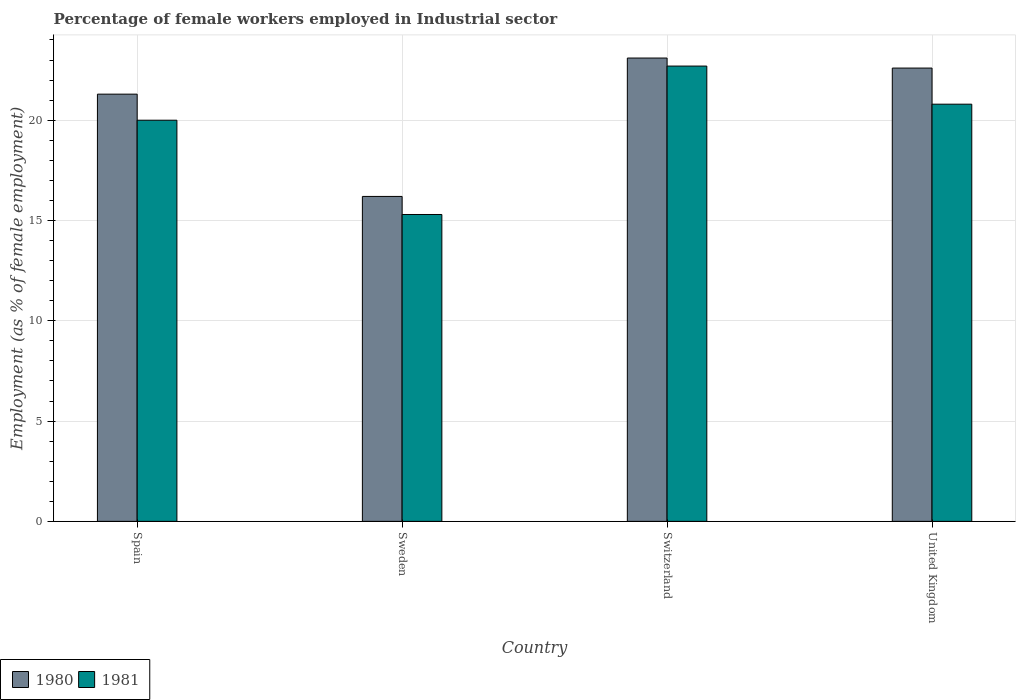How many different coloured bars are there?
Give a very brief answer. 2. How many groups of bars are there?
Provide a short and direct response. 4. Are the number of bars on each tick of the X-axis equal?
Your answer should be compact. Yes. In how many cases, is the number of bars for a given country not equal to the number of legend labels?
Offer a terse response. 0. What is the percentage of females employed in Industrial sector in 1980 in Switzerland?
Ensure brevity in your answer.  23.1. Across all countries, what is the maximum percentage of females employed in Industrial sector in 1980?
Provide a short and direct response. 23.1. Across all countries, what is the minimum percentage of females employed in Industrial sector in 1981?
Make the answer very short. 15.3. In which country was the percentage of females employed in Industrial sector in 1981 maximum?
Make the answer very short. Switzerland. In which country was the percentage of females employed in Industrial sector in 1980 minimum?
Make the answer very short. Sweden. What is the total percentage of females employed in Industrial sector in 1981 in the graph?
Ensure brevity in your answer.  78.8. What is the difference between the percentage of females employed in Industrial sector in 1981 in Sweden and that in Switzerland?
Keep it short and to the point. -7.4. What is the difference between the percentage of females employed in Industrial sector in 1980 in Sweden and the percentage of females employed in Industrial sector in 1981 in Spain?
Give a very brief answer. -3.8. What is the average percentage of females employed in Industrial sector in 1980 per country?
Ensure brevity in your answer.  20.8. What is the difference between the percentage of females employed in Industrial sector of/in 1980 and percentage of females employed in Industrial sector of/in 1981 in Switzerland?
Provide a short and direct response. 0.4. In how many countries, is the percentage of females employed in Industrial sector in 1981 greater than 4 %?
Give a very brief answer. 4. What is the ratio of the percentage of females employed in Industrial sector in 1980 in Sweden to that in Switzerland?
Your response must be concise. 0.7. Is the percentage of females employed in Industrial sector in 1981 in Spain less than that in United Kingdom?
Make the answer very short. Yes. What is the difference between the highest and the second highest percentage of females employed in Industrial sector in 1980?
Ensure brevity in your answer.  -1.3. What is the difference between the highest and the lowest percentage of females employed in Industrial sector in 1981?
Your answer should be very brief. 7.4. In how many countries, is the percentage of females employed in Industrial sector in 1980 greater than the average percentage of females employed in Industrial sector in 1980 taken over all countries?
Your answer should be very brief. 3. Is the sum of the percentage of females employed in Industrial sector in 1980 in Spain and Sweden greater than the maximum percentage of females employed in Industrial sector in 1981 across all countries?
Provide a short and direct response. Yes. What does the 1st bar from the right in United Kingdom represents?
Keep it short and to the point. 1981. Are all the bars in the graph horizontal?
Your answer should be compact. No. How many countries are there in the graph?
Offer a terse response. 4. Are the values on the major ticks of Y-axis written in scientific E-notation?
Keep it short and to the point. No. Does the graph contain any zero values?
Offer a terse response. No. Where does the legend appear in the graph?
Your answer should be compact. Bottom left. What is the title of the graph?
Offer a terse response. Percentage of female workers employed in Industrial sector. Does "1992" appear as one of the legend labels in the graph?
Keep it short and to the point. No. What is the label or title of the Y-axis?
Offer a very short reply. Employment (as % of female employment). What is the Employment (as % of female employment) in 1980 in Spain?
Offer a terse response. 21.3. What is the Employment (as % of female employment) of 1981 in Spain?
Your response must be concise. 20. What is the Employment (as % of female employment) in 1980 in Sweden?
Offer a terse response. 16.2. What is the Employment (as % of female employment) of 1981 in Sweden?
Your response must be concise. 15.3. What is the Employment (as % of female employment) of 1980 in Switzerland?
Give a very brief answer. 23.1. What is the Employment (as % of female employment) of 1981 in Switzerland?
Provide a short and direct response. 22.7. What is the Employment (as % of female employment) of 1980 in United Kingdom?
Provide a short and direct response. 22.6. What is the Employment (as % of female employment) in 1981 in United Kingdom?
Make the answer very short. 20.8. Across all countries, what is the maximum Employment (as % of female employment) of 1980?
Provide a short and direct response. 23.1. Across all countries, what is the maximum Employment (as % of female employment) in 1981?
Make the answer very short. 22.7. Across all countries, what is the minimum Employment (as % of female employment) of 1980?
Offer a terse response. 16.2. Across all countries, what is the minimum Employment (as % of female employment) of 1981?
Provide a succinct answer. 15.3. What is the total Employment (as % of female employment) in 1980 in the graph?
Ensure brevity in your answer.  83.2. What is the total Employment (as % of female employment) in 1981 in the graph?
Your response must be concise. 78.8. What is the difference between the Employment (as % of female employment) in 1980 in Spain and that in Sweden?
Your answer should be compact. 5.1. What is the difference between the Employment (as % of female employment) of 1981 in Spain and that in Sweden?
Give a very brief answer. 4.7. What is the difference between the Employment (as % of female employment) in 1981 in Spain and that in Switzerland?
Your response must be concise. -2.7. What is the difference between the Employment (as % of female employment) of 1980 in Sweden and that in Switzerland?
Give a very brief answer. -6.9. What is the difference between the Employment (as % of female employment) in 1981 in Switzerland and that in United Kingdom?
Offer a terse response. 1.9. What is the difference between the Employment (as % of female employment) in 1980 in Spain and the Employment (as % of female employment) in 1981 in United Kingdom?
Your response must be concise. 0.5. What is the difference between the Employment (as % of female employment) in 1980 in Sweden and the Employment (as % of female employment) in 1981 in Switzerland?
Provide a succinct answer. -6.5. What is the difference between the Employment (as % of female employment) of 1980 in Sweden and the Employment (as % of female employment) of 1981 in United Kingdom?
Your answer should be very brief. -4.6. What is the difference between the Employment (as % of female employment) of 1980 in Switzerland and the Employment (as % of female employment) of 1981 in United Kingdom?
Your answer should be very brief. 2.3. What is the average Employment (as % of female employment) of 1980 per country?
Keep it short and to the point. 20.8. What is the average Employment (as % of female employment) in 1981 per country?
Ensure brevity in your answer.  19.7. What is the difference between the Employment (as % of female employment) of 1980 and Employment (as % of female employment) of 1981 in United Kingdom?
Provide a short and direct response. 1.8. What is the ratio of the Employment (as % of female employment) of 1980 in Spain to that in Sweden?
Ensure brevity in your answer.  1.31. What is the ratio of the Employment (as % of female employment) of 1981 in Spain to that in Sweden?
Your answer should be compact. 1.31. What is the ratio of the Employment (as % of female employment) of 1980 in Spain to that in Switzerland?
Your response must be concise. 0.92. What is the ratio of the Employment (as % of female employment) in 1981 in Spain to that in Switzerland?
Offer a terse response. 0.88. What is the ratio of the Employment (as % of female employment) in 1980 in Spain to that in United Kingdom?
Provide a short and direct response. 0.94. What is the ratio of the Employment (as % of female employment) of 1981 in Spain to that in United Kingdom?
Your answer should be very brief. 0.96. What is the ratio of the Employment (as % of female employment) in 1980 in Sweden to that in Switzerland?
Give a very brief answer. 0.7. What is the ratio of the Employment (as % of female employment) of 1981 in Sweden to that in Switzerland?
Ensure brevity in your answer.  0.67. What is the ratio of the Employment (as % of female employment) of 1980 in Sweden to that in United Kingdom?
Your response must be concise. 0.72. What is the ratio of the Employment (as % of female employment) of 1981 in Sweden to that in United Kingdom?
Ensure brevity in your answer.  0.74. What is the ratio of the Employment (as % of female employment) in 1980 in Switzerland to that in United Kingdom?
Your answer should be compact. 1.02. What is the ratio of the Employment (as % of female employment) in 1981 in Switzerland to that in United Kingdom?
Make the answer very short. 1.09. What is the difference between the highest and the second highest Employment (as % of female employment) in 1980?
Provide a succinct answer. 0.5. What is the difference between the highest and the lowest Employment (as % of female employment) in 1981?
Offer a very short reply. 7.4. 